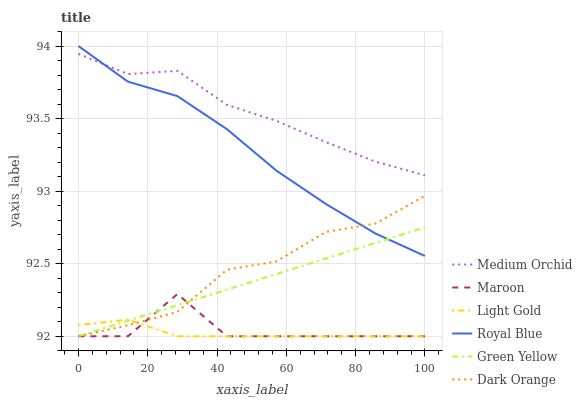Does Light Gold have the minimum area under the curve?
Answer yes or no. Yes. Does Medium Orchid have the maximum area under the curve?
Answer yes or no. Yes. Does Maroon have the minimum area under the curve?
Answer yes or no. No. Does Maroon have the maximum area under the curve?
Answer yes or no. No. Is Green Yellow the smoothest?
Answer yes or no. Yes. Is Maroon the roughest?
Answer yes or no. Yes. Is Medium Orchid the smoothest?
Answer yes or no. No. Is Medium Orchid the roughest?
Answer yes or no. No. Does Dark Orange have the lowest value?
Answer yes or no. Yes. Does Medium Orchid have the lowest value?
Answer yes or no. No. Does Royal Blue have the highest value?
Answer yes or no. Yes. Does Medium Orchid have the highest value?
Answer yes or no. No. Is Maroon less than Royal Blue?
Answer yes or no. Yes. Is Medium Orchid greater than Dark Orange?
Answer yes or no. Yes. Does Light Gold intersect Dark Orange?
Answer yes or no. Yes. Is Light Gold less than Dark Orange?
Answer yes or no. No. Is Light Gold greater than Dark Orange?
Answer yes or no. No. Does Maroon intersect Royal Blue?
Answer yes or no. No. 